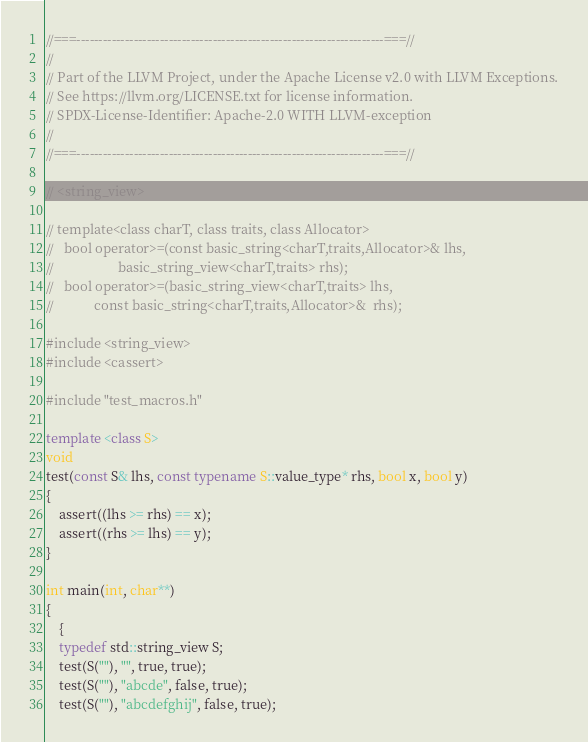<code> <loc_0><loc_0><loc_500><loc_500><_C++_>//===----------------------------------------------------------------------===//
//
// Part of the LLVM Project, under the Apache License v2.0 with LLVM Exceptions.
// See https://llvm.org/LICENSE.txt for license information.
// SPDX-License-Identifier: Apache-2.0 WITH LLVM-exception
//
//===----------------------------------------------------------------------===//

// <string_view>

// template<class charT, class traits, class Allocator>
//   bool operator>=(const basic_string<charT,traits,Allocator>& lhs,
//                   basic_string_view<charT,traits> rhs);
//   bool operator>=(basic_string_view<charT,traits> lhs,
//            const basic_string<charT,traits,Allocator>&  rhs);

#include <string_view>
#include <cassert>

#include "test_macros.h"

template <class S>
void
test(const S& lhs, const typename S::value_type* rhs, bool x, bool y)
{
    assert((lhs >= rhs) == x);
    assert((rhs >= lhs) == y);
}

int main(int, char**)
{
    {
    typedef std::string_view S;
    test(S(""), "", true, true);
    test(S(""), "abcde", false, true);
    test(S(""), "abcdefghij", false, true);</code> 